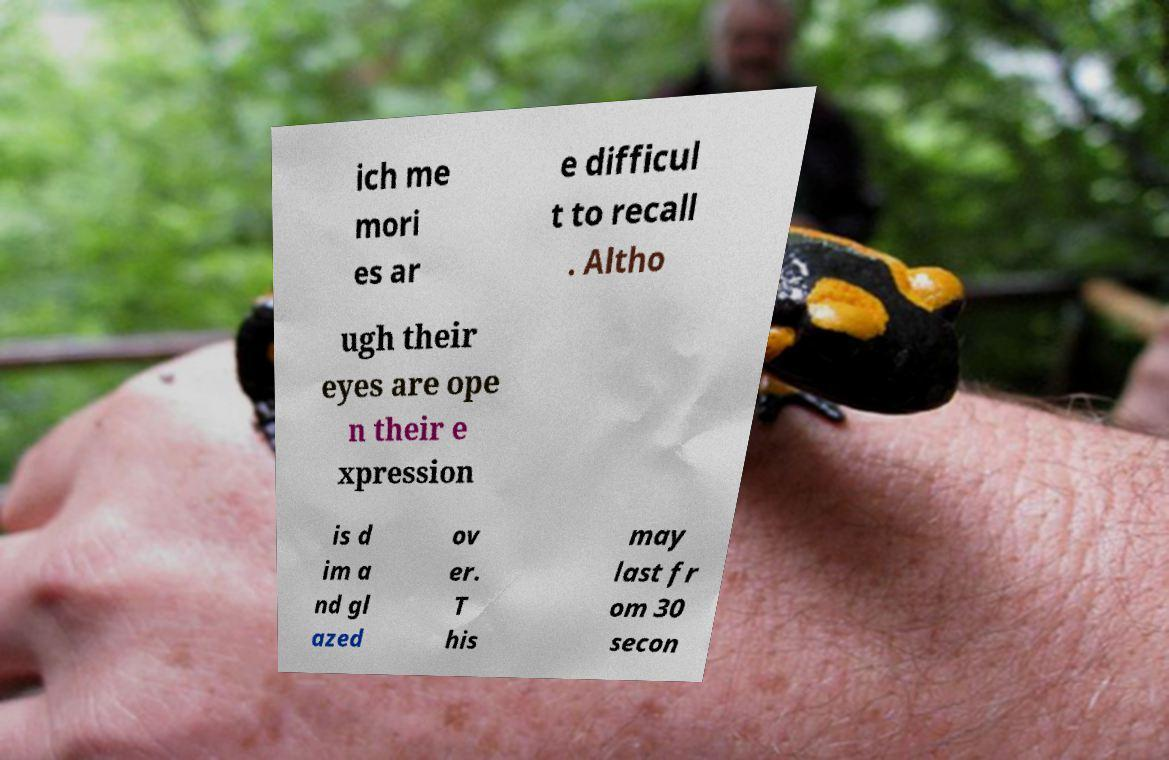Can you accurately transcribe the text from the provided image for me? ich me mori es ar e difficul t to recall . Altho ugh their eyes are ope n their e xpression is d im a nd gl azed ov er. T his may last fr om 30 secon 